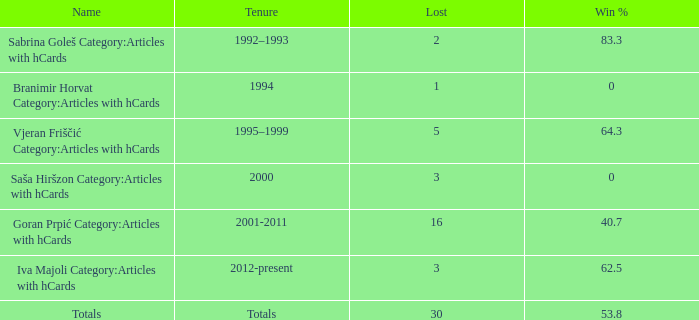I want the total number of ties for win % more than 0 and tenure of 2001-2011 with lost more than 16 0.0. 